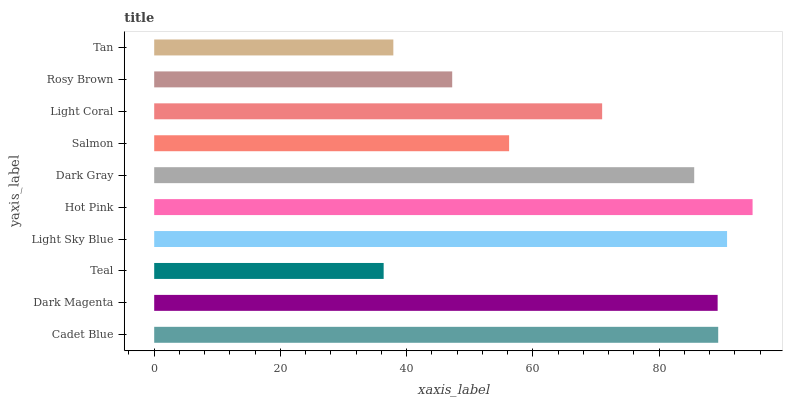Is Teal the minimum?
Answer yes or no. Yes. Is Hot Pink the maximum?
Answer yes or no. Yes. Is Dark Magenta the minimum?
Answer yes or no. No. Is Dark Magenta the maximum?
Answer yes or no. No. Is Cadet Blue greater than Dark Magenta?
Answer yes or no. Yes. Is Dark Magenta less than Cadet Blue?
Answer yes or no. Yes. Is Dark Magenta greater than Cadet Blue?
Answer yes or no. No. Is Cadet Blue less than Dark Magenta?
Answer yes or no. No. Is Dark Gray the high median?
Answer yes or no. Yes. Is Light Coral the low median?
Answer yes or no. Yes. Is Tan the high median?
Answer yes or no. No. Is Light Sky Blue the low median?
Answer yes or no. No. 